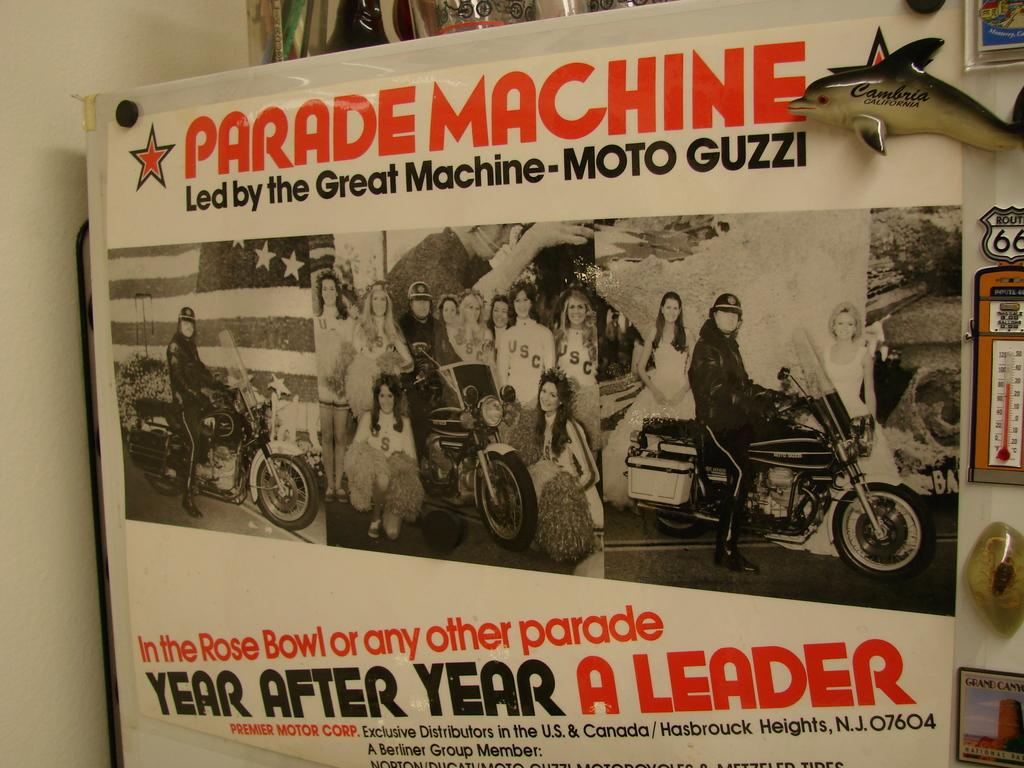<image>
Summarize the visual content of the image. Poster showing people on a motorcycle and says "year after year". 